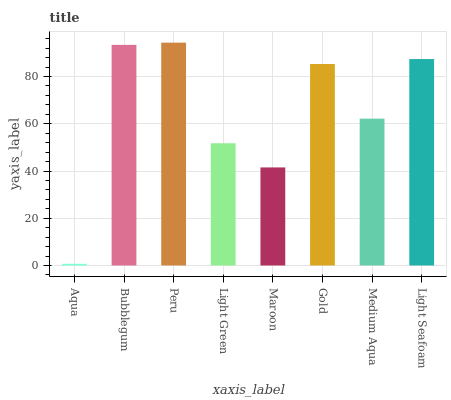Is Bubblegum the minimum?
Answer yes or no. No. Is Bubblegum the maximum?
Answer yes or no. No. Is Bubblegum greater than Aqua?
Answer yes or no. Yes. Is Aqua less than Bubblegum?
Answer yes or no. Yes. Is Aqua greater than Bubblegum?
Answer yes or no. No. Is Bubblegum less than Aqua?
Answer yes or no. No. Is Gold the high median?
Answer yes or no. Yes. Is Medium Aqua the low median?
Answer yes or no. Yes. Is Medium Aqua the high median?
Answer yes or no. No. Is Gold the low median?
Answer yes or no. No. 